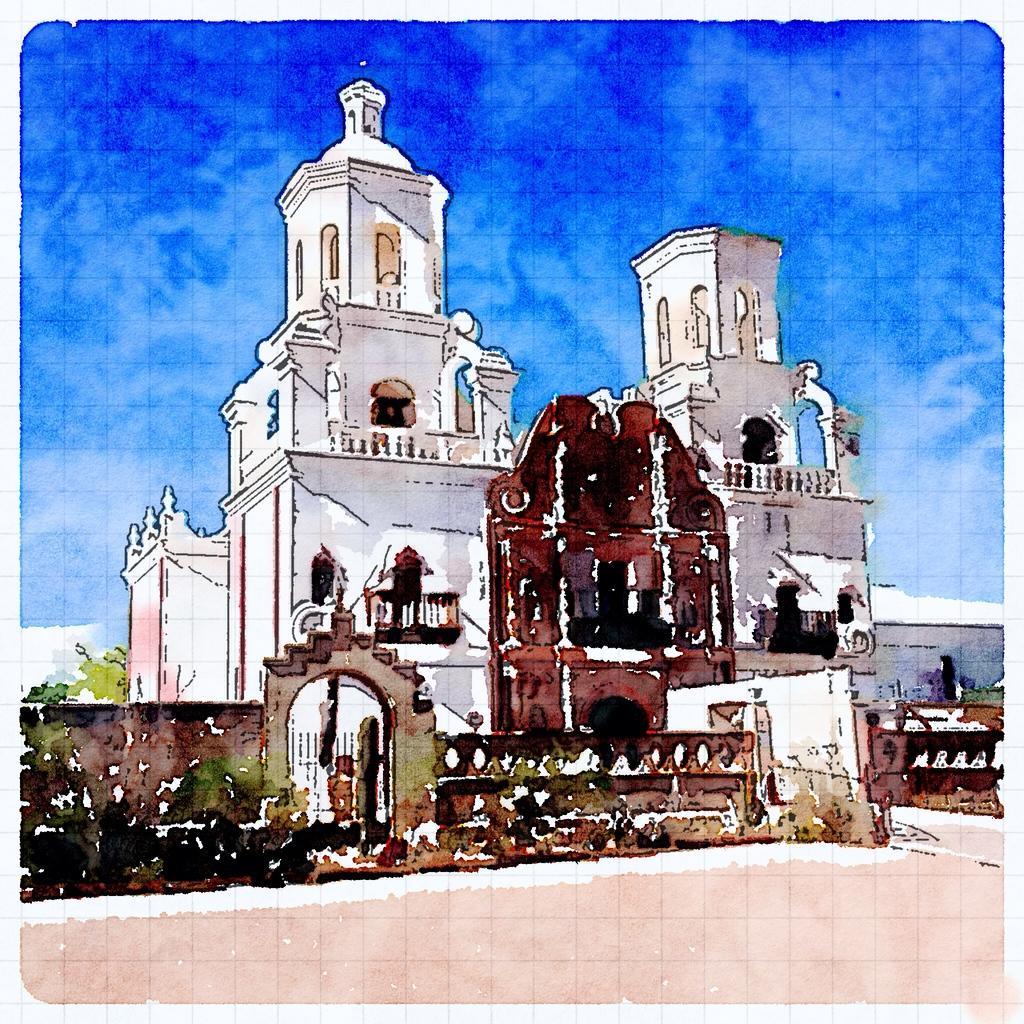In one or two sentences, can you explain what this image depicts? This is an edited image, In this picture we can see building. In the background of the image we can see sky with clouds. 